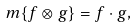<formula> <loc_0><loc_0><loc_500><loc_500>\ m \{ f \otimes g \} = f \cdot g ,</formula> 